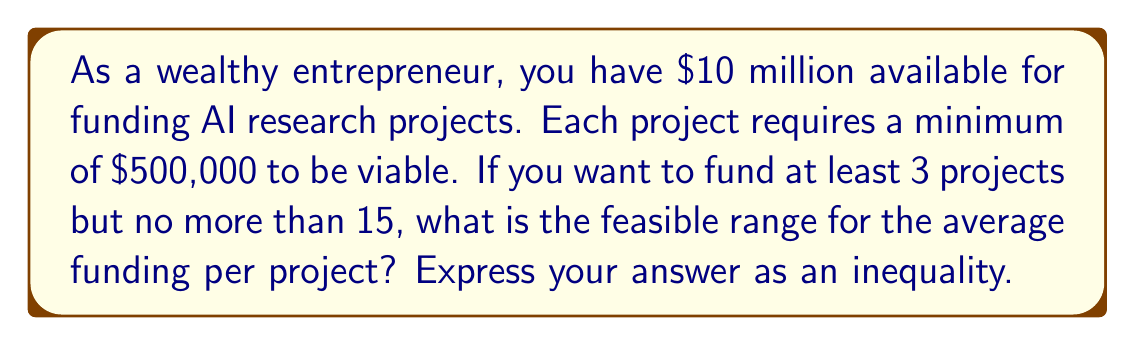Give your solution to this math problem. Let's approach this step-by-step:

1) Let $x$ be the average funding per project in millions of dollars.

2) Given:
   - Total available funding: $10 million
   - Minimum number of projects: 3
   - Maximum number of projects: 15
   - Minimum funding per project: $500,000 = $0.5 million

3) For the minimum number of projects (3):
   $$3x \leq 10$$
   $$x \leq \frac{10}{3}$$

4) For the maximum number of projects (15):
   $$15x \geq 10$$
   $$x \geq \frac{2}{3}$$

5) The minimum funding constraint:
   $$x \geq 0.5$$

6) Combining these inequalities:
   $$\max(0.5, \frac{2}{3}) \leq x \leq \frac{10}{3}$$
   $$\frac{2}{3} \leq x \leq \frac{10}{3}$$

Therefore, the feasible range for the average funding per project is:
$$\frac{2}{3} \leq x \leq \frac{10}{3}$$
Answer: $\frac{2}{3} \leq x \leq \frac{10}{3}$ 